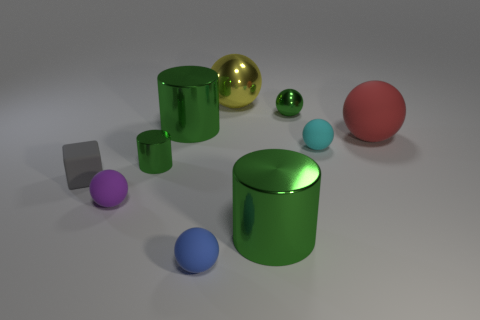Subtract all purple matte spheres. How many spheres are left? 5 Subtract all green balls. How many balls are left? 5 Subtract all spheres. How many objects are left? 4 Subtract all gray balls. Subtract all blue cylinders. How many balls are left? 6 Subtract all gray cylinders. How many red spheres are left? 1 Subtract all blocks. Subtract all small green balls. How many objects are left? 8 Add 2 metallic balls. How many metallic balls are left? 4 Add 7 blocks. How many blocks exist? 8 Subtract 0 purple cubes. How many objects are left? 10 Subtract 1 blocks. How many blocks are left? 0 